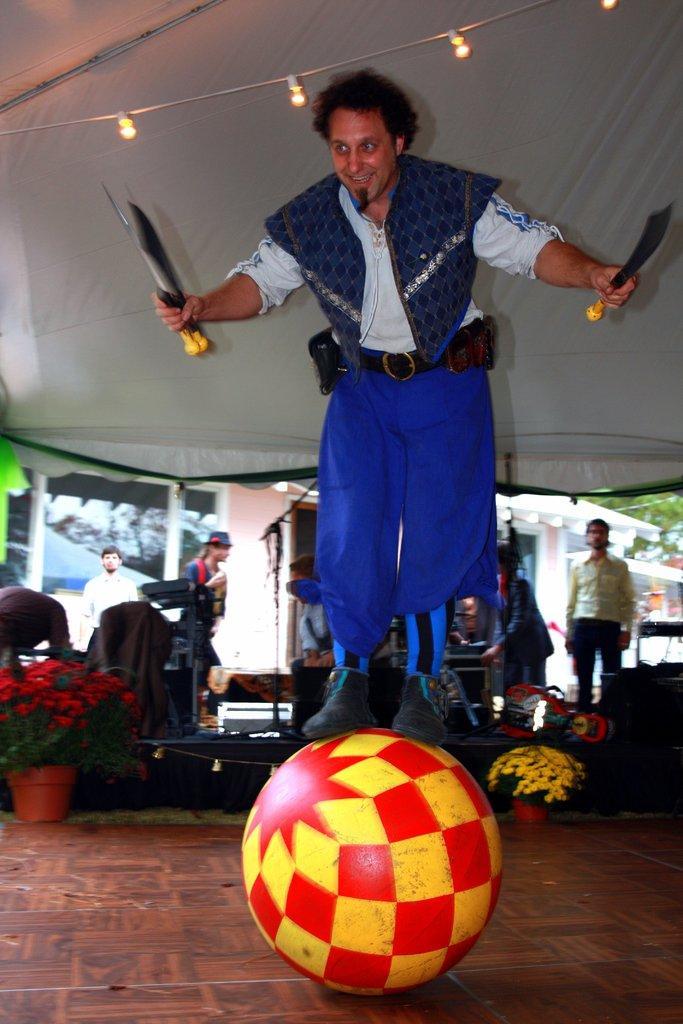Can you describe this image briefly? In this image there is a person standing on the ball, which is on the floor and he is holding a few objects in his hands and above him there are few lights hanging from the tent. In the background there are a few people standing, there are few flower pots, instruments and buildings. 